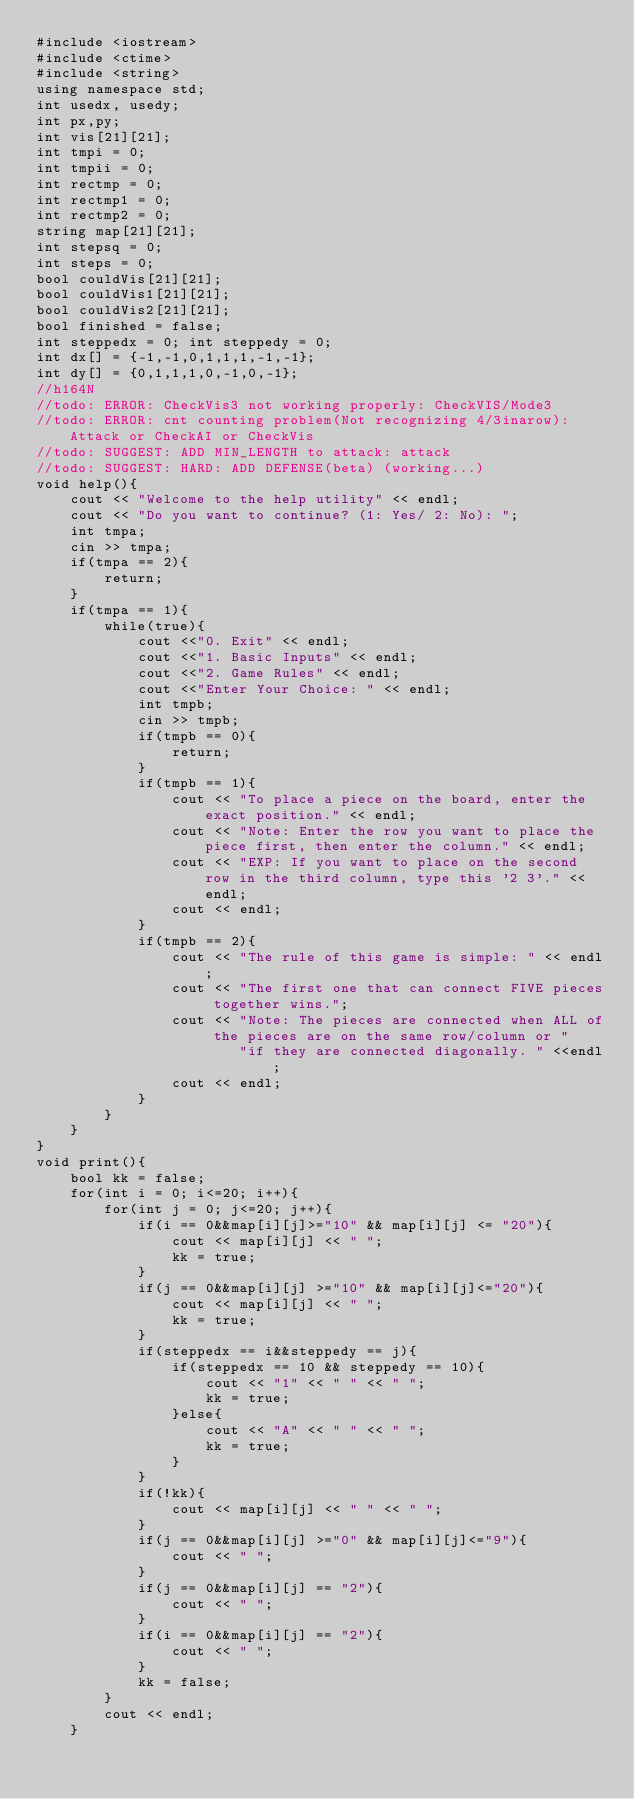<code> <loc_0><loc_0><loc_500><loc_500><_C++_>#include <iostream>
#include <ctime>
#include <string>
using namespace std;
int usedx, usedy;
int px,py;
int vis[21][21];
int tmpi = 0;
int tmpii = 0;
int rectmp = 0;
int rectmp1 = 0;
int rectmp2 = 0;
string map[21][21];
int stepsq = 0;
int steps = 0;
bool couldVis[21][21];
bool couldVis1[21][21];
bool couldVis2[21][21];
bool finished = false;
int steppedx = 0; int steppedy = 0;
int dx[] = {-1,-1,0,1,1,1,-1,-1};
int dy[] = {0,1,1,1,0,-1,0,-1};
//h164N
//todo: ERROR: CheckVis3 not working properly: CheckVIS/Mode3
//todo: ERROR: cnt counting problem(Not recognizing 4/3inarow): Attack or CheckAI or CheckVis
//todo: SUGGEST: ADD MIN_LENGTH to attack: attack
//todo: SUGGEST: HARD: ADD DEFENSE(beta) (working...)
void help(){
    cout << "Welcome to the help utility" << endl;
    cout << "Do you want to continue? (1: Yes/ 2: No): ";
    int tmpa;
    cin >> tmpa;
    if(tmpa == 2){
        return;
    }
    if(tmpa == 1){
        while(true){
            cout <<"0. Exit" << endl;
            cout <<"1. Basic Inputs" << endl;
            cout <<"2. Game Rules" << endl;
            cout <<"Enter Your Choice: " << endl;
            int tmpb;
            cin >> tmpb;
            if(tmpb == 0){
                return;
            }
            if(tmpb == 1){
                cout << "To place a piece on the board, enter the exact position." << endl;
                cout << "Note: Enter the row you want to place the piece first, then enter the column." << endl;
                cout << "EXP: If you want to place on the second row in the third column, type this '2 3'." << endl;
                cout << endl;
            }
            if(tmpb == 2){
                cout << "The rule of this game is simple: " << endl;
                cout << "The first one that can connect FIVE pieces together wins.";
                cout << "Note: The pieces are connected when ALL of the pieces are on the same row/column or "
                        "if they are connected diagonally. " <<endl;
                cout << endl;
            }
        }
    }
}
void print(){
    bool kk = false;
    for(int i = 0; i<=20; i++){
        for(int j = 0; j<=20; j++){
            if(i == 0&&map[i][j]>="10" && map[i][j] <= "20"){
                cout << map[i][j] << " ";
                kk = true;
            }
            if(j == 0&&map[i][j] >="10" && map[i][j]<="20"){
                cout << map[i][j] << " ";
                kk = true;
            }
            if(steppedx == i&&steppedy == j){
                if(steppedx == 10 && steppedy == 10){
                    cout << "1" << " " << " ";
                    kk = true;
                }else{
                    cout << "A" << " " << " ";
                    kk = true;
                }
            }
            if(!kk){
                cout << map[i][j] << " " << " ";
            }
            if(j == 0&&map[i][j] >="0" && map[i][j]<="9"){
                cout << " ";
            }
            if(j == 0&&map[i][j] == "2"){
                cout << " ";
            }
            if(i == 0&&map[i][j] == "2"){
                cout << " ";
            }
            kk = false;
        }
        cout << endl;
    }</code> 